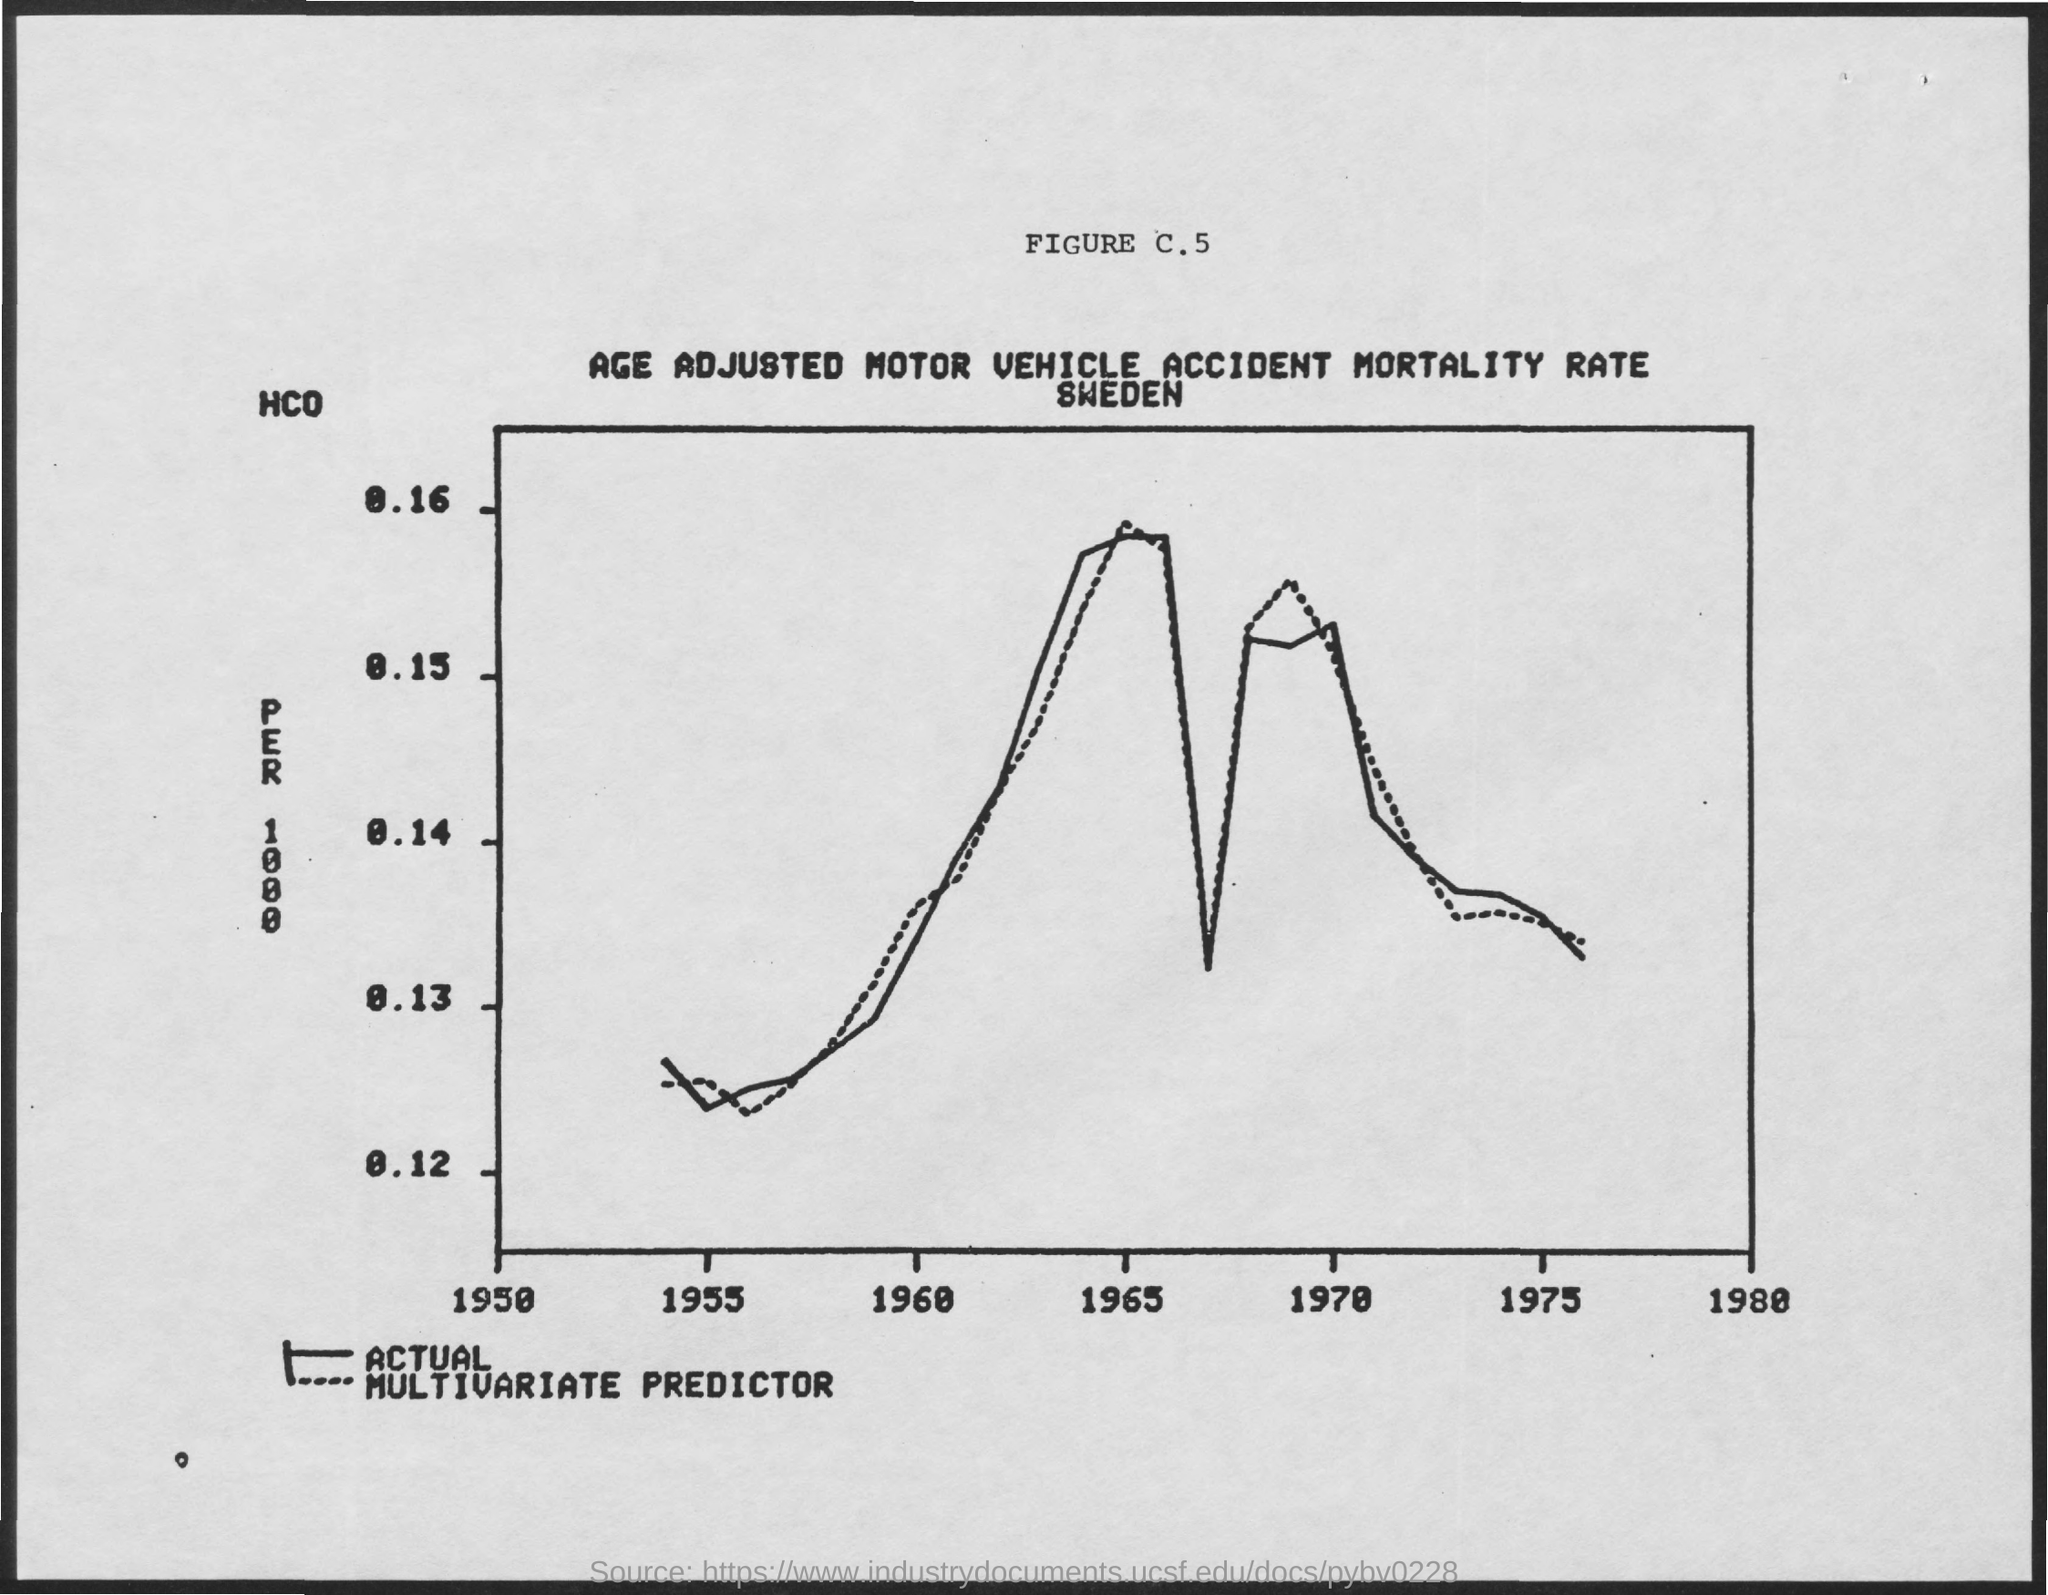Which year is mentioned last in the x axis?
Keep it short and to the point. 1980. 